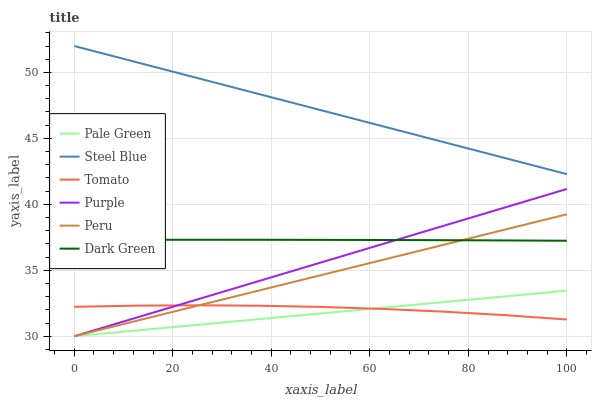Does Pale Green have the minimum area under the curve?
Answer yes or no. Yes. Does Steel Blue have the maximum area under the curve?
Answer yes or no. Yes. Does Purple have the minimum area under the curve?
Answer yes or no. No. Does Purple have the maximum area under the curve?
Answer yes or no. No. Is Steel Blue the smoothest?
Answer yes or no. Yes. Is Tomato the roughest?
Answer yes or no. Yes. Is Purple the smoothest?
Answer yes or no. No. Is Purple the roughest?
Answer yes or no. No. Does Purple have the lowest value?
Answer yes or no. Yes. Does Steel Blue have the lowest value?
Answer yes or no. No. Does Steel Blue have the highest value?
Answer yes or no. Yes. Does Purple have the highest value?
Answer yes or no. No. Is Purple less than Steel Blue?
Answer yes or no. Yes. Is Steel Blue greater than Pale Green?
Answer yes or no. Yes. Does Purple intersect Pale Green?
Answer yes or no. Yes. Is Purple less than Pale Green?
Answer yes or no. No. Is Purple greater than Pale Green?
Answer yes or no. No. Does Purple intersect Steel Blue?
Answer yes or no. No. 